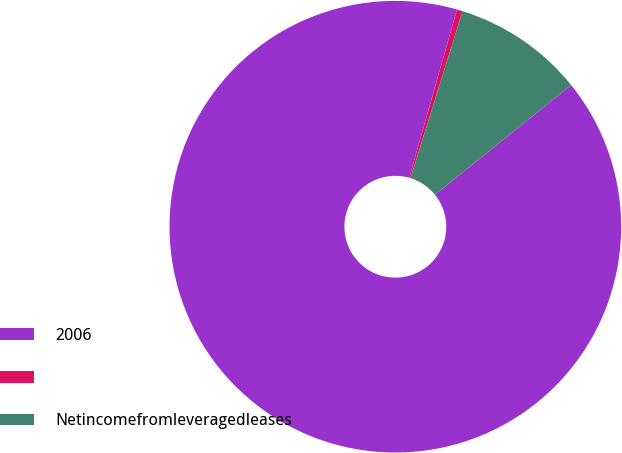<chart> <loc_0><loc_0><loc_500><loc_500><pie_chart><fcel>2006<fcel>Unnamed: 1<fcel>Netincomefromleveragedleases<nl><fcel>90.21%<fcel>0.41%<fcel>9.39%<nl></chart> 